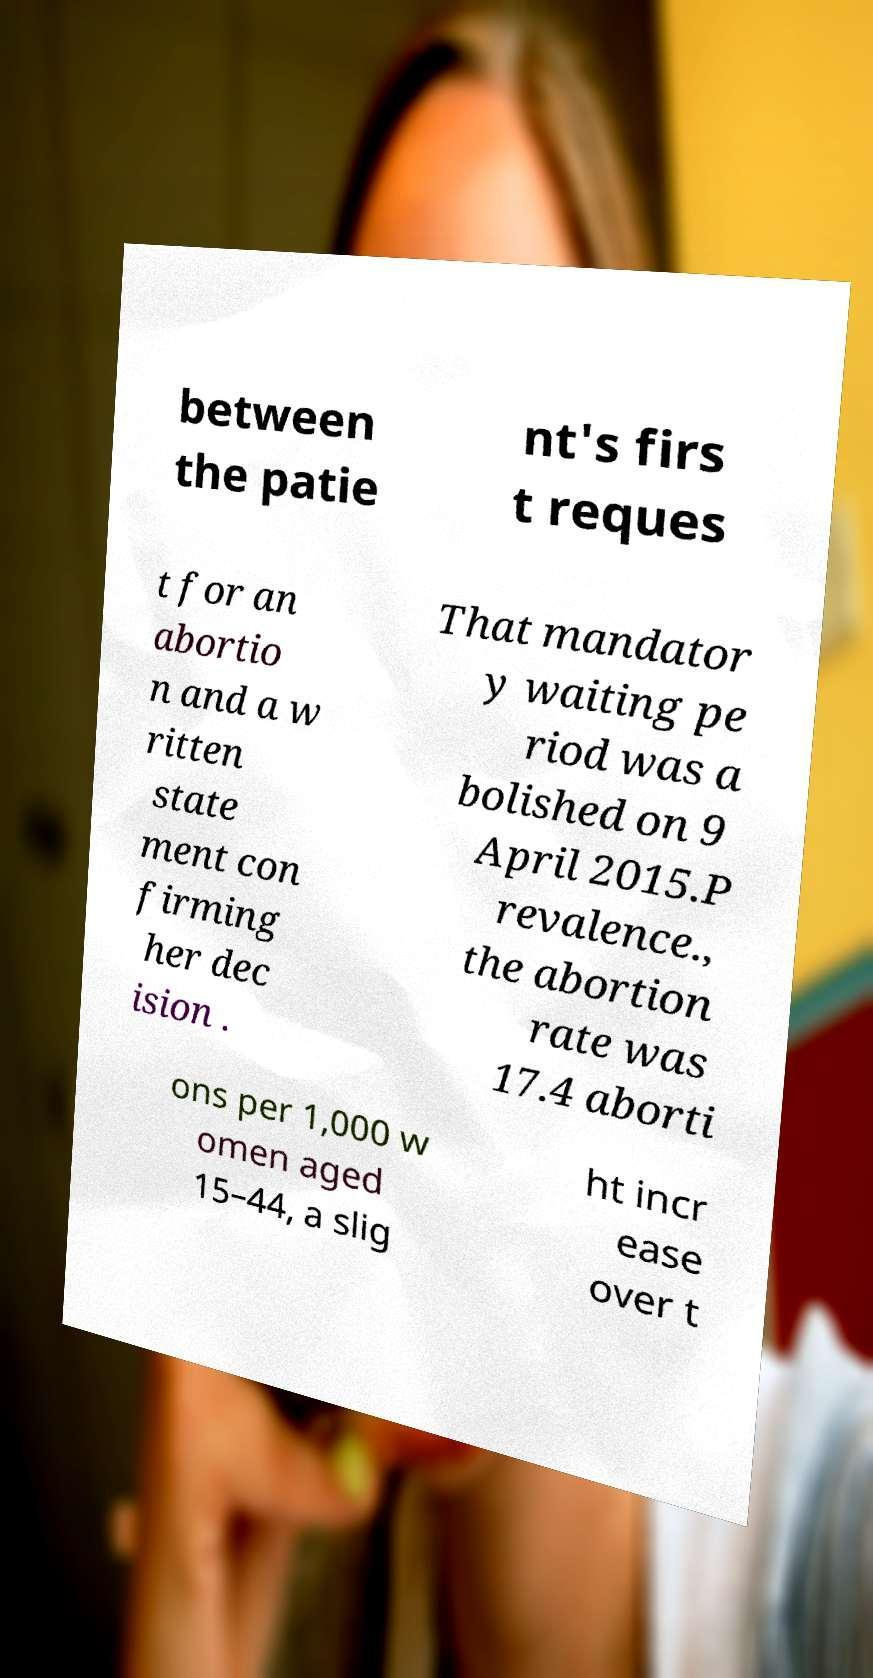What messages or text are displayed in this image? I need them in a readable, typed format. between the patie nt's firs t reques t for an abortio n and a w ritten state ment con firming her dec ision . That mandator y waiting pe riod was a bolished on 9 April 2015.P revalence., the abortion rate was 17.4 aborti ons per 1,000 w omen aged 15–44, a slig ht incr ease over t 